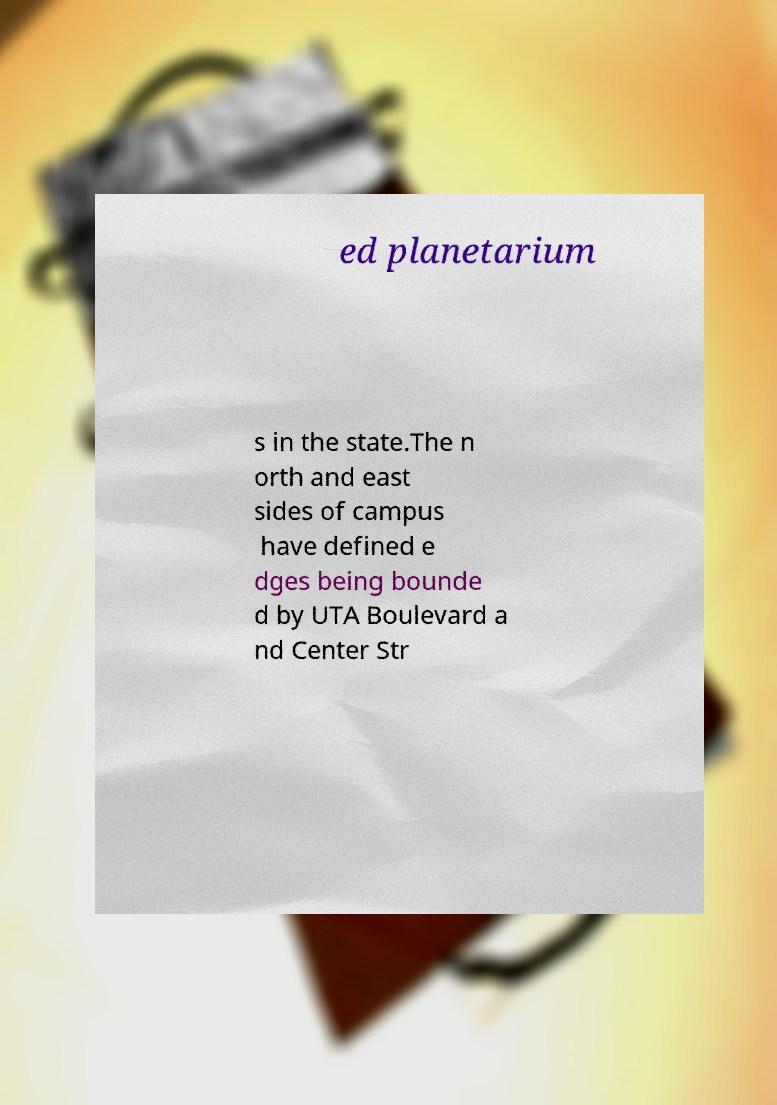There's text embedded in this image that I need extracted. Can you transcribe it verbatim? ed planetarium s in the state.The n orth and east sides of campus have defined e dges being bounde d by UTA Boulevard a nd Center Str 